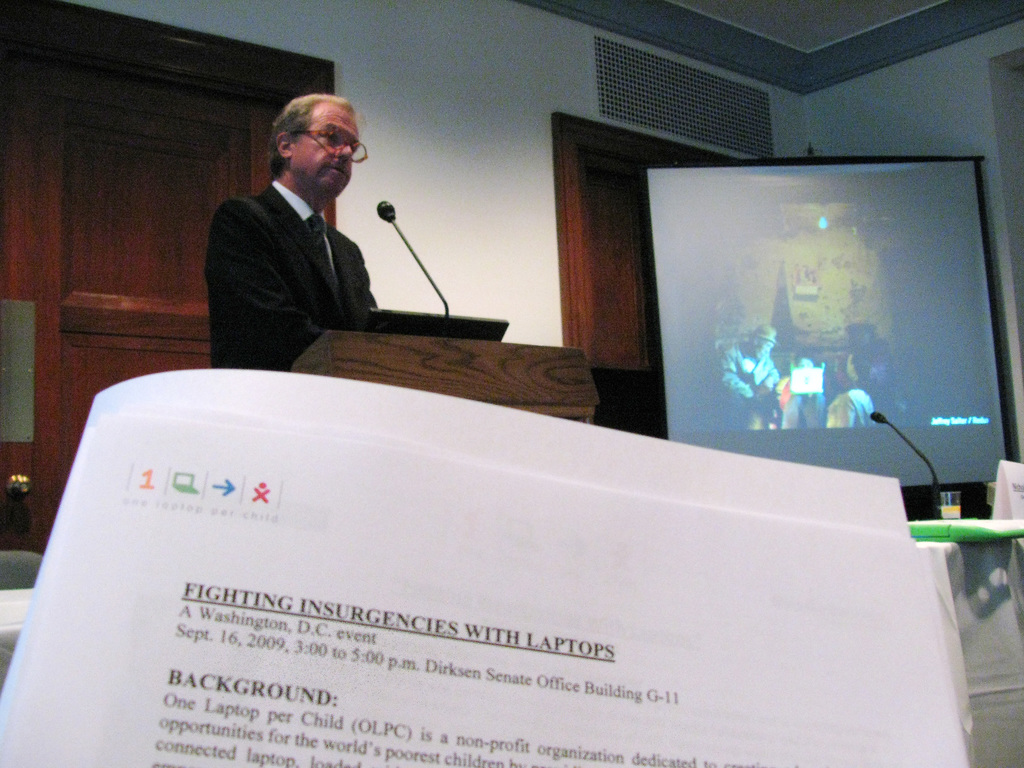How does the 'One Laptop per Child' initiative relate to the theme of the event described in the image? The 'One Laptop per Child' initiative seeks to provide affordable educational devices to children in underdeveloped regions, aiming to boost education and empower youth. The event 'Fighting Insurgencies with Laptops' likely discusses how equipping children with technology can be a powerful tool in stabilizing regions and preventing conflicts, aligning with OLPC's broader mission to educate and connect the world's poorest children. 